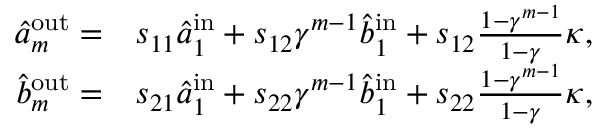Convert formula to latex. <formula><loc_0><loc_0><loc_500><loc_500>\begin{array} { r l } { \hat { a } _ { m } ^ { o u t } = } & { s _ { 1 1 } \hat { a } _ { 1 } ^ { i n } + s _ { 1 2 } \gamma ^ { m - 1 } \hat { b } _ { 1 } ^ { i n } + s _ { 1 2 } \frac { 1 - \gamma ^ { m - 1 } } { 1 - \gamma } \kappa , } \\ { \hat { b } _ { m } ^ { o u t } = } & { s _ { 2 1 } \hat { a } _ { 1 } ^ { i n } + s _ { 2 2 } \gamma ^ { m - 1 } \hat { b } _ { 1 } ^ { i n } + s _ { 2 2 } \frac { 1 - \gamma ^ { m - 1 } } { 1 - \gamma } \kappa , } \end{array}</formula> 